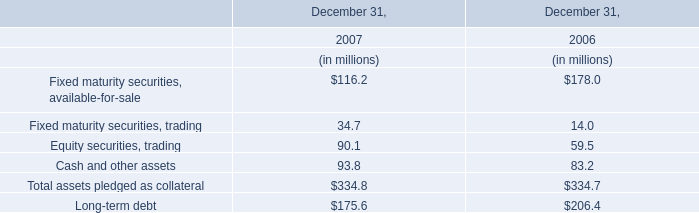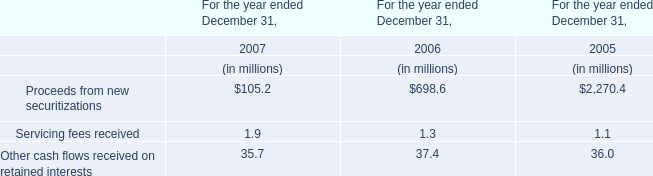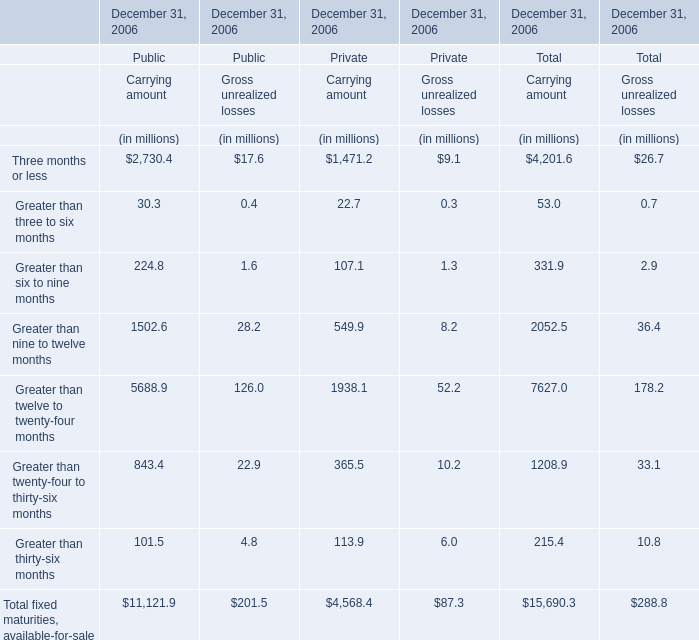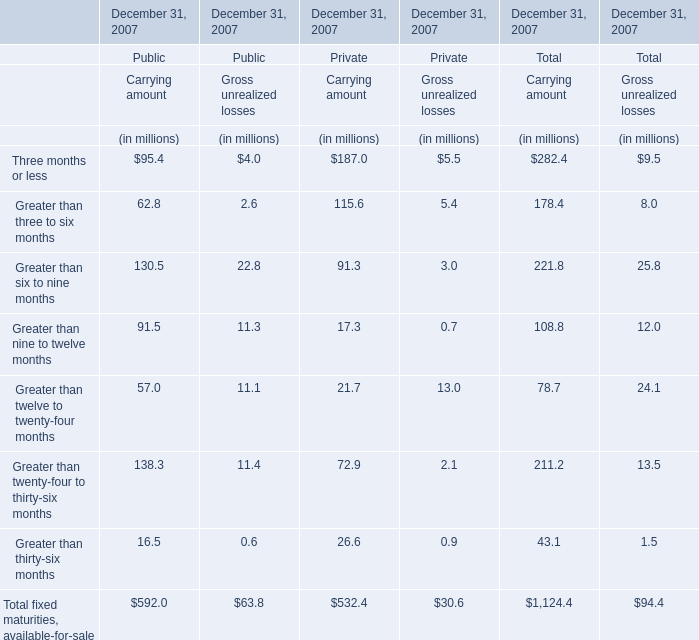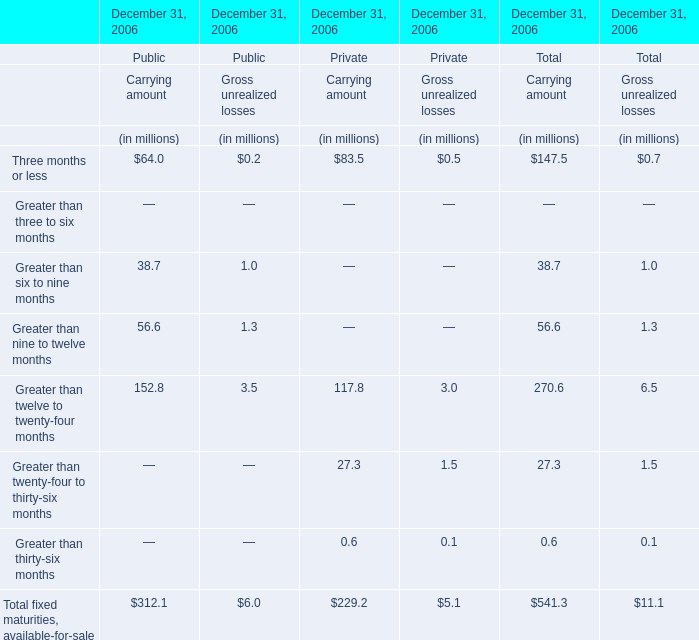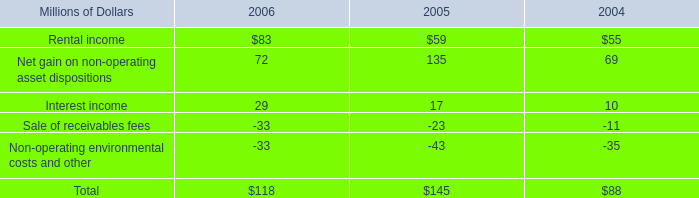what was the percentage change in rental income from 2005 to 2006? 
Computations: ((83 - 59) / 59)
Answer: 0.40678. 